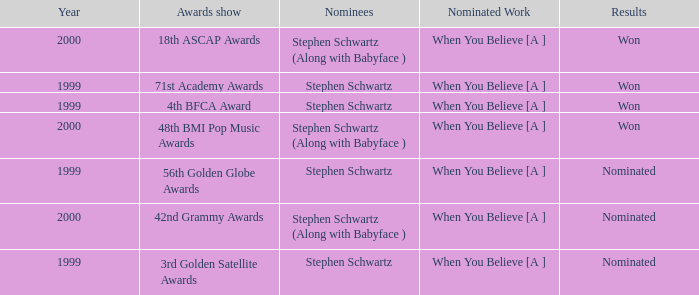What were the outcomes of the 71st academy awards ceremony? Won. 